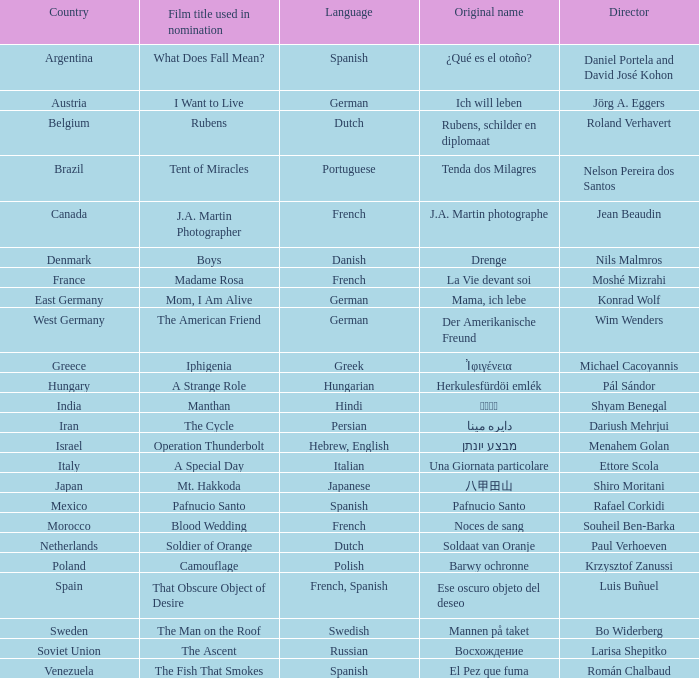Which director is from Italy? Ettore Scola. 